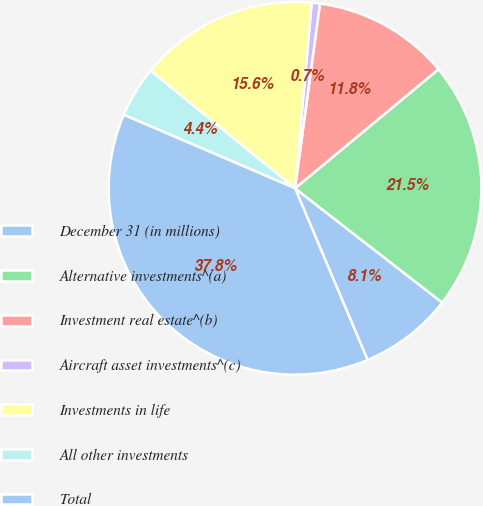<chart> <loc_0><loc_0><loc_500><loc_500><pie_chart><fcel>December 31 (in millions)<fcel>Alternative investments^(a)<fcel>Investment real estate^(b)<fcel>Aircraft asset investments^(c)<fcel>Investments in life<fcel>All other investments<fcel>Total<nl><fcel>8.13%<fcel>21.53%<fcel>11.84%<fcel>0.71%<fcel>15.55%<fcel>4.42%<fcel>37.81%<nl></chart> 